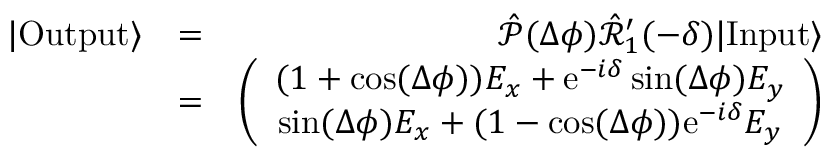Convert formula to latex. <formula><loc_0><loc_0><loc_500><loc_500>\begin{array} { r l r } { | O u t p u t \rangle } & { = } & { \hat { \mathcal { P } } ( \Delta \phi ) \hat { \mathcal { R } } _ { 1 } ^ { \prime } ( - \delta ) | I n p u t \rangle } \\ & { = } & { \left ( \begin{array} { c } { ( 1 + \cos ( \Delta \phi ) ) E _ { x } + e ^ { - i \delta } \sin ( \Delta \phi ) E _ { y } } \\ { \sin ( \Delta \phi ) E _ { x } + ( 1 - \cos ( \Delta \phi ) ) e ^ { - i \delta } E _ { y } } \end{array} \right ) } \end{array}</formula> 